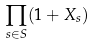<formula> <loc_0><loc_0><loc_500><loc_500>\prod _ { s \in S } ( 1 + X _ { s } )</formula> 